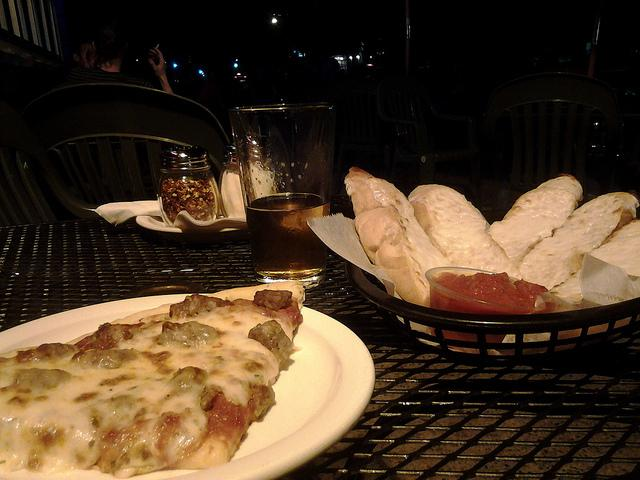What is the bread in? Please explain your reasoning. basket. The bread is inside a container that is not a box. there are no dogs or cats near the bread. 